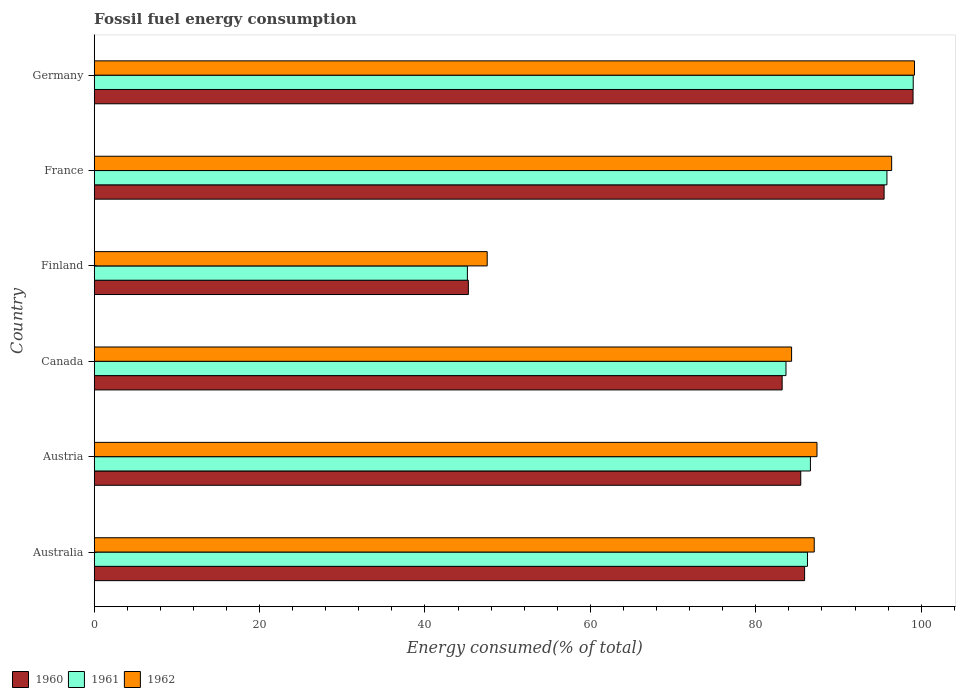How many groups of bars are there?
Keep it short and to the point. 6. Are the number of bars on each tick of the Y-axis equal?
Your answer should be very brief. Yes. How many bars are there on the 1st tick from the top?
Provide a succinct answer. 3. How many bars are there on the 4th tick from the bottom?
Offer a very short reply. 3. What is the label of the 2nd group of bars from the top?
Offer a very short reply. France. In how many cases, is the number of bars for a given country not equal to the number of legend labels?
Offer a terse response. 0. What is the percentage of energy consumed in 1961 in Canada?
Ensure brevity in your answer.  83.65. Across all countries, what is the maximum percentage of energy consumed in 1961?
Offer a terse response. 99.04. Across all countries, what is the minimum percentage of energy consumed in 1961?
Your response must be concise. 45.13. In which country was the percentage of energy consumed in 1960 minimum?
Your answer should be very brief. Finland. What is the total percentage of energy consumed in 1960 in the graph?
Make the answer very short. 494.33. What is the difference between the percentage of energy consumed in 1962 in Australia and that in Austria?
Your response must be concise. -0.33. What is the difference between the percentage of energy consumed in 1962 in Finland and the percentage of energy consumed in 1961 in Austria?
Make the answer very short. -39.08. What is the average percentage of energy consumed in 1962 per country?
Ensure brevity in your answer.  83.66. What is the difference between the percentage of energy consumed in 1962 and percentage of energy consumed in 1960 in Finland?
Your answer should be very brief. 2.28. In how many countries, is the percentage of energy consumed in 1962 greater than 64 %?
Your answer should be very brief. 5. What is the ratio of the percentage of energy consumed in 1962 in Canada to that in Germany?
Offer a very short reply. 0.85. Is the percentage of energy consumed in 1960 in Austria less than that in Canada?
Provide a short and direct response. No. Is the difference between the percentage of energy consumed in 1962 in Canada and Finland greater than the difference between the percentage of energy consumed in 1960 in Canada and Finland?
Offer a terse response. No. What is the difference between the highest and the second highest percentage of energy consumed in 1962?
Ensure brevity in your answer.  2.76. What is the difference between the highest and the lowest percentage of energy consumed in 1961?
Give a very brief answer. 53.91. Is the sum of the percentage of energy consumed in 1961 in Canada and Germany greater than the maximum percentage of energy consumed in 1960 across all countries?
Provide a short and direct response. Yes. What does the 1st bar from the bottom in Finland represents?
Your answer should be very brief. 1960. Is it the case that in every country, the sum of the percentage of energy consumed in 1961 and percentage of energy consumed in 1960 is greater than the percentage of energy consumed in 1962?
Give a very brief answer. Yes. How many countries are there in the graph?
Keep it short and to the point. 6. Does the graph contain any zero values?
Offer a terse response. No. Where does the legend appear in the graph?
Make the answer very short. Bottom left. What is the title of the graph?
Give a very brief answer. Fossil fuel energy consumption. Does "1984" appear as one of the legend labels in the graph?
Make the answer very short. No. What is the label or title of the X-axis?
Offer a terse response. Energy consumed(% of total). What is the Energy consumed(% of total) of 1960 in Australia?
Give a very brief answer. 85.91. What is the Energy consumed(% of total) in 1961 in Australia?
Give a very brief answer. 86.25. What is the Energy consumed(% of total) in 1962 in Australia?
Provide a succinct answer. 87.07. What is the Energy consumed(% of total) in 1960 in Austria?
Your response must be concise. 85.44. What is the Energy consumed(% of total) in 1961 in Austria?
Ensure brevity in your answer.  86.61. What is the Energy consumed(% of total) of 1962 in Austria?
Make the answer very short. 87.4. What is the Energy consumed(% of total) of 1960 in Canada?
Keep it short and to the point. 83.19. What is the Energy consumed(% of total) of 1961 in Canada?
Your answer should be compact. 83.65. What is the Energy consumed(% of total) of 1962 in Canada?
Your answer should be very brief. 84.33. What is the Energy consumed(% of total) in 1960 in Finland?
Offer a very short reply. 45.25. What is the Energy consumed(% of total) of 1961 in Finland?
Make the answer very short. 45.13. What is the Energy consumed(% of total) of 1962 in Finland?
Your response must be concise. 47.52. What is the Energy consumed(% of total) of 1960 in France?
Give a very brief answer. 95.52. What is the Energy consumed(% of total) of 1961 in France?
Your answer should be very brief. 95.86. What is the Energy consumed(% of total) in 1962 in France?
Your answer should be very brief. 96.43. What is the Energy consumed(% of total) of 1960 in Germany?
Your answer should be compact. 99.02. What is the Energy consumed(% of total) of 1961 in Germany?
Provide a succinct answer. 99.04. What is the Energy consumed(% of total) of 1962 in Germany?
Your answer should be compact. 99.19. Across all countries, what is the maximum Energy consumed(% of total) in 1960?
Provide a succinct answer. 99.02. Across all countries, what is the maximum Energy consumed(% of total) of 1961?
Provide a succinct answer. 99.04. Across all countries, what is the maximum Energy consumed(% of total) in 1962?
Provide a succinct answer. 99.19. Across all countries, what is the minimum Energy consumed(% of total) of 1960?
Ensure brevity in your answer.  45.25. Across all countries, what is the minimum Energy consumed(% of total) of 1961?
Make the answer very short. 45.13. Across all countries, what is the minimum Energy consumed(% of total) of 1962?
Keep it short and to the point. 47.52. What is the total Energy consumed(% of total) of 1960 in the graph?
Provide a succinct answer. 494.33. What is the total Energy consumed(% of total) of 1961 in the graph?
Your answer should be very brief. 496.55. What is the total Energy consumed(% of total) in 1962 in the graph?
Offer a terse response. 501.96. What is the difference between the Energy consumed(% of total) of 1960 in Australia and that in Austria?
Give a very brief answer. 0.47. What is the difference between the Energy consumed(% of total) in 1961 in Australia and that in Austria?
Ensure brevity in your answer.  -0.36. What is the difference between the Energy consumed(% of total) of 1962 in Australia and that in Austria?
Offer a terse response. -0.33. What is the difference between the Energy consumed(% of total) in 1960 in Australia and that in Canada?
Provide a short and direct response. 2.71. What is the difference between the Energy consumed(% of total) of 1961 in Australia and that in Canada?
Offer a very short reply. 2.6. What is the difference between the Energy consumed(% of total) in 1962 in Australia and that in Canada?
Keep it short and to the point. 2.74. What is the difference between the Energy consumed(% of total) in 1960 in Australia and that in Finland?
Ensure brevity in your answer.  40.66. What is the difference between the Energy consumed(% of total) in 1961 in Australia and that in Finland?
Make the answer very short. 41.12. What is the difference between the Energy consumed(% of total) of 1962 in Australia and that in Finland?
Your answer should be very brief. 39.55. What is the difference between the Energy consumed(% of total) of 1960 in Australia and that in France?
Make the answer very short. -9.61. What is the difference between the Energy consumed(% of total) in 1961 in Australia and that in France?
Keep it short and to the point. -9.61. What is the difference between the Energy consumed(% of total) of 1962 in Australia and that in France?
Your response must be concise. -9.36. What is the difference between the Energy consumed(% of total) of 1960 in Australia and that in Germany?
Your response must be concise. -13.11. What is the difference between the Energy consumed(% of total) in 1961 in Australia and that in Germany?
Provide a succinct answer. -12.79. What is the difference between the Energy consumed(% of total) in 1962 in Australia and that in Germany?
Ensure brevity in your answer.  -12.12. What is the difference between the Energy consumed(% of total) of 1960 in Austria and that in Canada?
Your answer should be very brief. 2.25. What is the difference between the Energy consumed(% of total) in 1961 in Austria and that in Canada?
Keep it short and to the point. 2.95. What is the difference between the Energy consumed(% of total) in 1962 in Austria and that in Canada?
Offer a very short reply. 3.07. What is the difference between the Energy consumed(% of total) of 1960 in Austria and that in Finland?
Your answer should be very brief. 40.19. What is the difference between the Energy consumed(% of total) in 1961 in Austria and that in Finland?
Your response must be concise. 41.48. What is the difference between the Energy consumed(% of total) in 1962 in Austria and that in Finland?
Your response must be concise. 39.88. What is the difference between the Energy consumed(% of total) of 1960 in Austria and that in France?
Ensure brevity in your answer.  -10.08. What is the difference between the Energy consumed(% of total) in 1961 in Austria and that in France?
Offer a terse response. -9.25. What is the difference between the Energy consumed(% of total) of 1962 in Austria and that in France?
Your answer should be very brief. -9.03. What is the difference between the Energy consumed(% of total) in 1960 in Austria and that in Germany?
Make the answer very short. -13.58. What is the difference between the Energy consumed(% of total) in 1961 in Austria and that in Germany?
Offer a very short reply. -12.43. What is the difference between the Energy consumed(% of total) of 1962 in Austria and that in Germany?
Provide a succinct answer. -11.79. What is the difference between the Energy consumed(% of total) in 1960 in Canada and that in Finland?
Give a very brief answer. 37.95. What is the difference between the Energy consumed(% of total) in 1961 in Canada and that in Finland?
Offer a terse response. 38.53. What is the difference between the Energy consumed(% of total) of 1962 in Canada and that in Finland?
Provide a succinct answer. 36.81. What is the difference between the Energy consumed(% of total) in 1960 in Canada and that in France?
Offer a terse response. -12.33. What is the difference between the Energy consumed(% of total) in 1961 in Canada and that in France?
Offer a very short reply. -12.21. What is the difference between the Energy consumed(% of total) in 1962 in Canada and that in France?
Your answer should be very brief. -12.1. What is the difference between the Energy consumed(% of total) in 1960 in Canada and that in Germany?
Your response must be concise. -15.83. What is the difference between the Energy consumed(% of total) of 1961 in Canada and that in Germany?
Offer a terse response. -15.39. What is the difference between the Energy consumed(% of total) in 1962 in Canada and that in Germany?
Give a very brief answer. -14.86. What is the difference between the Energy consumed(% of total) in 1960 in Finland and that in France?
Give a very brief answer. -50.27. What is the difference between the Energy consumed(% of total) in 1961 in Finland and that in France?
Your response must be concise. -50.73. What is the difference between the Energy consumed(% of total) of 1962 in Finland and that in France?
Your response must be concise. -48.91. What is the difference between the Energy consumed(% of total) in 1960 in Finland and that in Germany?
Your response must be concise. -53.77. What is the difference between the Energy consumed(% of total) of 1961 in Finland and that in Germany?
Offer a very short reply. -53.91. What is the difference between the Energy consumed(% of total) in 1962 in Finland and that in Germany?
Provide a short and direct response. -51.67. What is the difference between the Energy consumed(% of total) in 1961 in France and that in Germany?
Provide a succinct answer. -3.18. What is the difference between the Energy consumed(% of total) of 1962 in France and that in Germany?
Give a very brief answer. -2.76. What is the difference between the Energy consumed(% of total) in 1960 in Australia and the Energy consumed(% of total) in 1961 in Austria?
Provide a succinct answer. -0.7. What is the difference between the Energy consumed(% of total) in 1960 in Australia and the Energy consumed(% of total) in 1962 in Austria?
Ensure brevity in your answer.  -1.5. What is the difference between the Energy consumed(% of total) in 1961 in Australia and the Energy consumed(% of total) in 1962 in Austria?
Offer a very short reply. -1.15. What is the difference between the Energy consumed(% of total) in 1960 in Australia and the Energy consumed(% of total) in 1961 in Canada?
Your answer should be compact. 2.25. What is the difference between the Energy consumed(% of total) of 1960 in Australia and the Energy consumed(% of total) of 1962 in Canada?
Your answer should be compact. 1.57. What is the difference between the Energy consumed(% of total) in 1961 in Australia and the Energy consumed(% of total) in 1962 in Canada?
Provide a succinct answer. 1.92. What is the difference between the Energy consumed(% of total) in 1960 in Australia and the Energy consumed(% of total) in 1961 in Finland?
Your answer should be compact. 40.78. What is the difference between the Energy consumed(% of total) in 1960 in Australia and the Energy consumed(% of total) in 1962 in Finland?
Ensure brevity in your answer.  38.38. What is the difference between the Energy consumed(% of total) of 1961 in Australia and the Energy consumed(% of total) of 1962 in Finland?
Your answer should be very brief. 38.73. What is the difference between the Energy consumed(% of total) of 1960 in Australia and the Energy consumed(% of total) of 1961 in France?
Your response must be concise. -9.96. What is the difference between the Energy consumed(% of total) of 1960 in Australia and the Energy consumed(% of total) of 1962 in France?
Your response must be concise. -10.53. What is the difference between the Energy consumed(% of total) of 1961 in Australia and the Energy consumed(% of total) of 1962 in France?
Your answer should be compact. -10.18. What is the difference between the Energy consumed(% of total) of 1960 in Australia and the Energy consumed(% of total) of 1961 in Germany?
Your response must be concise. -13.13. What is the difference between the Energy consumed(% of total) in 1960 in Australia and the Energy consumed(% of total) in 1962 in Germany?
Ensure brevity in your answer.  -13.29. What is the difference between the Energy consumed(% of total) of 1961 in Australia and the Energy consumed(% of total) of 1962 in Germany?
Keep it short and to the point. -12.94. What is the difference between the Energy consumed(% of total) in 1960 in Austria and the Energy consumed(% of total) in 1961 in Canada?
Offer a very short reply. 1.79. What is the difference between the Energy consumed(% of total) of 1960 in Austria and the Energy consumed(% of total) of 1962 in Canada?
Make the answer very short. 1.11. What is the difference between the Energy consumed(% of total) of 1961 in Austria and the Energy consumed(% of total) of 1962 in Canada?
Ensure brevity in your answer.  2.28. What is the difference between the Energy consumed(% of total) of 1960 in Austria and the Energy consumed(% of total) of 1961 in Finland?
Keep it short and to the point. 40.31. What is the difference between the Energy consumed(% of total) of 1960 in Austria and the Energy consumed(% of total) of 1962 in Finland?
Keep it short and to the point. 37.92. What is the difference between the Energy consumed(% of total) in 1961 in Austria and the Energy consumed(% of total) in 1962 in Finland?
Your response must be concise. 39.08. What is the difference between the Energy consumed(% of total) in 1960 in Austria and the Energy consumed(% of total) in 1961 in France?
Your answer should be very brief. -10.42. What is the difference between the Energy consumed(% of total) in 1960 in Austria and the Energy consumed(% of total) in 1962 in France?
Your answer should be very brief. -10.99. What is the difference between the Energy consumed(% of total) of 1961 in Austria and the Energy consumed(% of total) of 1962 in France?
Provide a succinct answer. -9.82. What is the difference between the Energy consumed(% of total) of 1960 in Austria and the Energy consumed(% of total) of 1961 in Germany?
Your response must be concise. -13.6. What is the difference between the Energy consumed(% of total) in 1960 in Austria and the Energy consumed(% of total) in 1962 in Germany?
Offer a very short reply. -13.75. What is the difference between the Energy consumed(% of total) in 1961 in Austria and the Energy consumed(% of total) in 1962 in Germany?
Give a very brief answer. -12.58. What is the difference between the Energy consumed(% of total) in 1960 in Canada and the Energy consumed(% of total) in 1961 in Finland?
Your answer should be compact. 38.06. What is the difference between the Energy consumed(% of total) of 1960 in Canada and the Energy consumed(% of total) of 1962 in Finland?
Your answer should be very brief. 35.67. What is the difference between the Energy consumed(% of total) in 1961 in Canada and the Energy consumed(% of total) in 1962 in Finland?
Provide a short and direct response. 36.13. What is the difference between the Energy consumed(% of total) in 1960 in Canada and the Energy consumed(% of total) in 1961 in France?
Your answer should be very brief. -12.67. What is the difference between the Energy consumed(% of total) of 1960 in Canada and the Energy consumed(% of total) of 1962 in France?
Provide a short and direct response. -13.24. What is the difference between the Energy consumed(% of total) in 1961 in Canada and the Energy consumed(% of total) in 1962 in France?
Provide a succinct answer. -12.78. What is the difference between the Energy consumed(% of total) of 1960 in Canada and the Energy consumed(% of total) of 1961 in Germany?
Your answer should be compact. -15.85. What is the difference between the Energy consumed(% of total) of 1960 in Canada and the Energy consumed(% of total) of 1962 in Germany?
Your answer should be very brief. -16. What is the difference between the Energy consumed(% of total) in 1961 in Canada and the Energy consumed(% of total) in 1962 in Germany?
Provide a short and direct response. -15.54. What is the difference between the Energy consumed(% of total) of 1960 in Finland and the Energy consumed(% of total) of 1961 in France?
Provide a succinct answer. -50.62. What is the difference between the Energy consumed(% of total) of 1960 in Finland and the Energy consumed(% of total) of 1962 in France?
Provide a succinct answer. -51.19. What is the difference between the Energy consumed(% of total) in 1961 in Finland and the Energy consumed(% of total) in 1962 in France?
Your answer should be compact. -51.3. What is the difference between the Energy consumed(% of total) in 1960 in Finland and the Energy consumed(% of total) in 1961 in Germany?
Your answer should be very brief. -53.8. What is the difference between the Energy consumed(% of total) of 1960 in Finland and the Energy consumed(% of total) of 1962 in Germany?
Keep it short and to the point. -53.95. What is the difference between the Energy consumed(% of total) in 1961 in Finland and the Energy consumed(% of total) in 1962 in Germany?
Your answer should be compact. -54.06. What is the difference between the Energy consumed(% of total) of 1960 in France and the Energy consumed(% of total) of 1961 in Germany?
Make the answer very short. -3.52. What is the difference between the Energy consumed(% of total) of 1960 in France and the Energy consumed(% of total) of 1962 in Germany?
Your answer should be very brief. -3.67. What is the difference between the Energy consumed(% of total) in 1961 in France and the Energy consumed(% of total) in 1962 in Germany?
Your answer should be compact. -3.33. What is the average Energy consumed(% of total) in 1960 per country?
Provide a succinct answer. 82.39. What is the average Energy consumed(% of total) in 1961 per country?
Make the answer very short. 82.76. What is the average Energy consumed(% of total) in 1962 per country?
Give a very brief answer. 83.66. What is the difference between the Energy consumed(% of total) in 1960 and Energy consumed(% of total) in 1961 in Australia?
Give a very brief answer. -0.35. What is the difference between the Energy consumed(% of total) in 1960 and Energy consumed(% of total) in 1962 in Australia?
Provide a succinct answer. -1.16. What is the difference between the Energy consumed(% of total) of 1961 and Energy consumed(% of total) of 1962 in Australia?
Keep it short and to the point. -0.82. What is the difference between the Energy consumed(% of total) in 1960 and Energy consumed(% of total) in 1961 in Austria?
Keep it short and to the point. -1.17. What is the difference between the Energy consumed(% of total) in 1960 and Energy consumed(% of total) in 1962 in Austria?
Offer a very short reply. -1.96. What is the difference between the Energy consumed(% of total) in 1961 and Energy consumed(% of total) in 1962 in Austria?
Your answer should be very brief. -0.79. What is the difference between the Energy consumed(% of total) in 1960 and Energy consumed(% of total) in 1961 in Canada?
Offer a very short reply. -0.46. What is the difference between the Energy consumed(% of total) of 1960 and Energy consumed(% of total) of 1962 in Canada?
Offer a terse response. -1.14. What is the difference between the Energy consumed(% of total) in 1961 and Energy consumed(% of total) in 1962 in Canada?
Your response must be concise. -0.68. What is the difference between the Energy consumed(% of total) of 1960 and Energy consumed(% of total) of 1961 in Finland?
Give a very brief answer. 0.12. What is the difference between the Energy consumed(% of total) in 1960 and Energy consumed(% of total) in 1962 in Finland?
Your answer should be compact. -2.28. What is the difference between the Energy consumed(% of total) of 1961 and Energy consumed(% of total) of 1962 in Finland?
Your answer should be compact. -2.4. What is the difference between the Energy consumed(% of total) in 1960 and Energy consumed(% of total) in 1961 in France?
Provide a short and direct response. -0.34. What is the difference between the Energy consumed(% of total) of 1960 and Energy consumed(% of total) of 1962 in France?
Provide a succinct answer. -0.91. What is the difference between the Energy consumed(% of total) in 1961 and Energy consumed(% of total) in 1962 in France?
Give a very brief answer. -0.57. What is the difference between the Energy consumed(% of total) in 1960 and Energy consumed(% of total) in 1961 in Germany?
Keep it short and to the point. -0.02. What is the difference between the Energy consumed(% of total) of 1960 and Energy consumed(% of total) of 1962 in Germany?
Provide a succinct answer. -0.17. What is the difference between the Energy consumed(% of total) in 1961 and Energy consumed(% of total) in 1962 in Germany?
Ensure brevity in your answer.  -0.15. What is the ratio of the Energy consumed(% of total) in 1960 in Australia to that in Canada?
Offer a terse response. 1.03. What is the ratio of the Energy consumed(% of total) of 1961 in Australia to that in Canada?
Make the answer very short. 1.03. What is the ratio of the Energy consumed(% of total) in 1962 in Australia to that in Canada?
Your answer should be very brief. 1.03. What is the ratio of the Energy consumed(% of total) of 1960 in Australia to that in Finland?
Provide a short and direct response. 1.9. What is the ratio of the Energy consumed(% of total) in 1961 in Australia to that in Finland?
Give a very brief answer. 1.91. What is the ratio of the Energy consumed(% of total) of 1962 in Australia to that in Finland?
Your response must be concise. 1.83. What is the ratio of the Energy consumed(% of total) of 1960 in Australia to that in France?
Keep it short and to the point. 0.9. What is the ratio of the Energy consumed(% of total) of 1961 in Australia to that in France?
Provide a short and direct response. 0.9. What is the ratio of the Energy consumed(% of total) in 1962 in Australia to that in France?
Give a very brief answer. 0.9. What is the ratio of the Energy consumed(% of total) in 1960 in Australia to that in Germany?
Your response must be concise. 0.87. What is the ratio of the Energy consumed(% of total) in 1961 in Australia to that in Germany?
Your answer should be very brief. 0.87. What is the ratio of the Energy consumed(% of total) in 1962 in Australia to that in Germany?
Offer a very short reply. 0.88. What is the ratio of the Energy consumed(% of total) in 1960 in Austria to that in Canada?
Keep it short and to the point. 1.03. What is the ratio of the Energy consumed(% of total) in 1961 in Austria to that in Canada?
Provide a succinct answer. 1.04. What is the ratio of the Energy consumed(% of total) of 1962 in Austria to that in Canada?
Provide a short and direct response. 1.04. What is the ratio of the Energy consumed(% of total) in 1960 in Austria to that in Finland?
Keep it short and to the point. 1.89. What is the ratio of the Energy consumed(% of total) in 1961 in Austria to that in Finland?
Your response must be concise. 1.92. What is the ratio of the Energy consumed(% of total) of 1962 in Austria to that in Finland?
Keep it short and to the point. 1.84. What is the ratio of the Energy consumed(% of total) of 1960 in Austria to that in France?
Ensure brevity in your answer.  0.89. What is the ratio of the Energy consumed(% of total) of 1961 in Austria to that in France?
Provide a succinct answer. 0.9. What is the ratio of the Energy consumed(% of total) of 1962 in Austria to that in France?
Your answer should be compact. 0.91. What is the ratio of the Energy consumed(% of total) of 1960 in Austria to that in Germany?
Offer a terse response. 0.86. What is the ratio of the Energy consumed(% of total) of 1961 in Austria to that in Germany?
Provide a succinct answer. 0.87. What is the ratio of the Energy consumed(% of total) of 1962 in Austria to that in Germany?
Your response must be concise. 0.88. What is the ratio of the Energy consumed(% of total) in 1960 in Canada to that in Finland?
Provide a succinct answer. 1.84. What is the ratio of the Energy consumed(% of total) in 1961 in Canada to that in Finland?
Offer a terse response. 1.85. What is the ratio of the Energy consumed(% of total) in 1962 in Canada to that in Finland?
Ensure brevity in your answer.  1.77. What is the ratio of the Energy consumed(% of total) of 1960 in Canada to that in France?
Ensure brevity in your answer.  0.87. What is the ratio of the Energy consumed(% of total) of 1961 in Canada to that in France?
Provide a succinct answer. 0.87. What is the ratio of the Energy consumed(% of total) of 1962 in Canada to that in France?
Offer a very short reply. 0.87. What is the ratio of the Energy consumed(% of total) of 1960 in Canada to that in Germany?
Provide a succinct answer. 0.84. What is the ratio of the Energy consumed(% of total) of 1961 in Canada to that in Germany?
Your response must be concise. 0.84. What is the ratio of the Energy consumed(% of total) of 1962 in Canada to that in Germany?
Give a very brief answer. 0.85. What is the ratio of the Energy consumed(% of total) of 1960 in Finland to that in France?
Your answer should be very brief. 0.47. What is the ratio of the Energy consumed(% of total) of 1961 in Finland to that in France?
Offer a terse response. 0.47. What is the ratio of the Energy consumed(% of total) in 1962 in Finland to that in France?
Your answer should be very brief. 0.49. What is the ratio of the Energy consumed(% of total) of 1960 in Finland to that in Germany?
Provide a succinct answer. 0.46. What is the ratio of the Energy consumed(% of total) of 1961 in Finland to that in Germany?
Give a very brief answer. 0.46. What is the ratio of the Energy consumed(% of total) in 1962 in Finland to that in Germany?
Provide a short and direct response. 0.48. What is the ratio of the Energy consumed(% of total) of 1960 in France to that in Germany?
Make the answer very short. 0.96. What is the ratio of the Energy consumed(% of total) in 1961 in France to that in Germany?
Offer a terse response. 0.97. What is the ratio of the Energy consumed(% of total) in 1962 in France to that in Germany?
Provide a short and direct response. 0.97. What is the difference between the highest and the second highest Energy consumed(% of total) of 1960?
Provide a succinct answer. 3.5. What is the difference between the highest and the second highest Energy consumed(% of total) of 1961?
Your response must be concise. 3.18. What is the difference between the highest and the second highest Energy consumed(% of total) of 1962?
Offer a very short reply. 2.76. What is the difference between the highest and the lowest Energy consumed(% of total) of 1960?
Your answer should be very brief. 53.77. What is the difference between the highest and the lowest Energy consumed(% of total) of 1961?
Offer a very short reply. 53.91. What is the difference between the highest and the lowest Energy consumed(% of total) of 1962?
Your response must be concise. 51.67. 